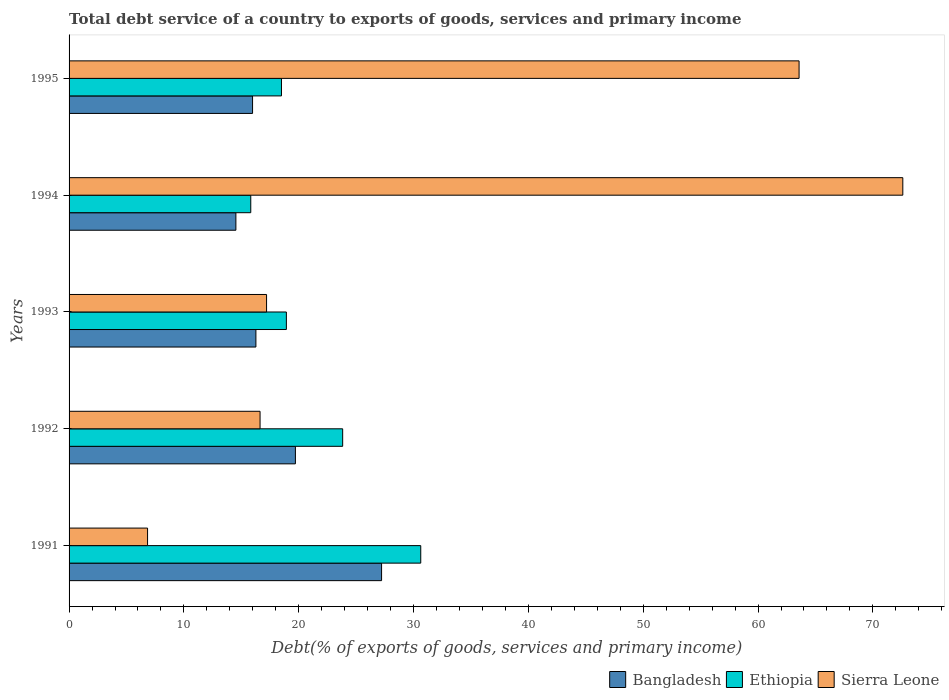How many groups of bars are there?
Ensure brevity in your answer.  5. Are the number of bars on each tick of the Y-axis equal?
Ensure brevity in your answer.  Yes. How many bars are there on the 2nd tick from the top?
Give a very brief answer. 3. How many bars are there on the 2nd tick from the bottom?
Keep it short and to the point. 3. What is the total debt service in Ethiopia in 1993?
Offer a terse response. 18.92. Across all years, what is the maximum total debt service in Sierra Leone?
Your response must be concise. 72.61. Across all years, what is the minimum total debt service in Ethiopia?
Your response must be concise. 15.82. What is the total total debt service in Ethiopia in the graph?
Offer a terse response. 107.7. What is the difference between the total debt service in Bangladesh in 1993 and that in 1994?
Your answer should be compact. 1.74. What is the difference between the total debt service in Bangladesh in 1991 and the total debt service in Ethiopia in 1995?
Offer a very short reply. 8.72. What is the average total debt service in Bangladesh per year?
Your response must be concise. 18.74. In the year 1991, what is the difference between the total debt service in Bangladesh and total debt service in Sierra Leone?
Offer a very short reply. 20.38. What is the ratio of the total debt service in Ethiopia in 1994 to that in 1995?
Give a very brief answer. 0.86. Is the total debt service in Ethiopia in 1994 less than that in 1995?
Your answer should be compact. Yes. What is the difference between the highest and the second highest total debt service in Ethiopia?
Offer a very short reply. 6.8. What is the difference between the highest and the lowest total debt service in Bangladesh?
Ensure brevity in your answer.  12.69. In how many years, is the total debt service in Bangladesh greater than the average total debt service in Bangladesh taken over all years?
Your answer should be compact. 2. What does the 3rd bar from the top in 1993 represents?
Your response must be concise. Bangladesh. Is it the case that in every year, the sum of the total debt service in Bangladesh and total debt service in Ethiopia is greater than the total debt service in Sierra Leone?
Offer a terse response. No. How many years are there in the graph?
Your response must be concise. 5. Does the graph contain grids?
Your answer should be compact. No. Where does the legend appear in the graph?
Offer a terse response. Bottom right. How are the legend labels stacked?
Make the answer very short. Horizontal. What is the title of the graph?
Keep it short and to the point. Total debt service of a country to exports of goods, services and primary income. What is the label or title of the X-axis?
Give a very brief answer. Debt(% of exports of goods, services and primary income). What is the Debt(% of exports of goods, services and primary income) in Bangladesh in 1991?
Ensure brevity in your answer.  27.21. What is the Debt(% of exports of goods, services and primary income) of Ethiopia in 1991?
Give a very brief answer. 30.63. What is the Debt(% of exports of goods, services and primary income) in Sierra Leone in 1991?
Make the answer very short. 6.84. What is the Debt(% of exports of goods, services and primary income) of Bangladesh in 1992?
Give a very brief answer. 19.71. What is the Debt(% of exports of goods, services and primary income) in Ethiopia in 1992?
Your answer should be very brief. 23.83. What is the Debt(% of exports of goods, services and primary income) of Sierra Leone in 1992?
Offer a terse response. 16.63. What is the Debt(% of exports of goods, services and primary income) of Bangladesh in 1993?
Provide a short and direct response. 16.27. What is the Debt(% of exports of goods, services and primary income) of Ethiopia in 1993?
Make the answer very short. 18.92. What is the Debt(% of exports of goods, services and primary income) in Sierra Leone in 1993?
Offer a terse response. 17.2. What is the Debt(% of exports of goods, services and primary income) in Bangladesh in 1994?
Offer a terse response. 14.53. What is the Debt(% of exports of goods, services and primary income) of Ethiopia in 1994?
Your response must be concise. 15.82. What is the Debt(% of exports of goods, services and primary income) in Sierra Leone in 1994?
Your answer should be very brief. 72.61. What is the Debt(% of exports of goods, services and primary income) in Bangladesh in 1995?
Make the answer very short. 15.98. What is the Debt(% of exports of goods, services and primary income) of Ethiopia in 1995?
Your response must be concise. 18.5. What is the Debt(% of exports of goods, services and primary income) of Sierra Leone in 1995?
Offer a terse response. 63.57. Across all years, what is the maximum Debt(% of exports of goods, services and primary income) in Bangladesh?
Offer a terse response. 27.21. Across all years, what is the maximum Debt(% of exports of goods, services and primary income) of Ethiopia?
Offer a terse response. 30.63. Across all years, what is the maximum Debt(% of exports of goods, services and primary income) of Sierra Leone?
Provide a short and direct response. 72.61. Across all years, what is the minimum Debt(% of exports of goods, services and primary income) of Bangladesh?
Your answer should be very brief. 14.53. Across all years, what is the minimum Debt(% of exports of goods, services and primary income) of Ethiopia?
Make the answer very short. 15.82. Across all years, what is the minimum Debt(% of exports of goods, services and primary income) of Sierra Leone?
Keep it short and to the point. 6.84. What is the total Debt(% of exports of goods, services and primary income) of Bangladesh in the graph?
Offer a terse response. 93.7. What is the total Debt(% of exports of goods, services and primary income) in Ethiopia in the graph?
Give a very brief answer. 107.7. What is the total Debt(% of exports of goods, services and primary income) in Sierra Leone in the graph?
Offer a terse response. 176.84. What is the difference between the Debt(% of exports of goods, services and primary income) of Bangladesh in 1991 and that in 1992?
Provide a short and direct response. 7.5. What is the difference between the Debt(% of exports of goods, services and primary income) of Ethiopia in 1991 and that in 1992?
Your answer should be very brief. 6.8. What is the difference between the Debt(% of exports of goods, services and primary income) of Sierra Leone in 1991 and that in 1992?
Offer a very short reply. -9.8. What is the difference between the Debt(% of exports of goods, services and primary income) of Bangladesh in 1991 and that in 1993?
Offer a terse response. 10.94. What is the difference between the Debt(% of exports of goods, services and primary income) in Ethiopia in 1991 and that in 1993?
Provide a succinct answer. 11.7. What is the difference between the Debt(% of exports of goods, services and primary income) of Sierra Leone in 1991 and that in 1993?
Give a very brief answer. -10.36. What is the difference between the Debt(% of exports of goods, services and primary income) of Bangladesh in 1991 and that in 1994?
Offer a terse response. 12.69. What is the difference between the Debt(% of exports of goods, services and primary income) in Ethiopia in 1991 and that in 1994?
Your answer should be very brief. 14.8. What is the difference between the Debt(% of exports of goods, services and primary income) of Sierra Leone in 1991 and that in 1994?
Provide a short and direct response. -65.77. What is the difference between the Debt(% of exports of goods, services and primary income) in Bangladesh in 1991 and that in 1995?
Provide a short and direct response. 11.24. What is the difference between the Debt(% of exports of goods, services and primary income) in Ethiopia in 1991 and that in 1995?
Your response must be concise. 12.13. What is the difference between the Debt(% of exports of goods, services and primary income) of Sierra Leone in 1991 and that in 1995?
Provide a short and direct response. -56.74. What is the difference between the Debt(% of exports of goods, services and primary income) in Bangladesh in 1992 and that in 1993?
Your answer should be compact. 3.44. What is the difference between the Debt(% of exports of goods, services and primary income) in Ethiopia in 1992 and that in 1993?
Your answer should be very brief. 4.9. What is the difference between the Debt(% of exports of goods, services and primary income) in Sierra Leone in 1992 and that in 1993?
Provide a succinct answer. -0.57. What is the difference between the Debt(% of exports of goods, services and primary income) of Bangladesh in 1992 and that in 1994?
Provide a succinct answer. 5.18. What is the difference between the Debt(% of exports of goods, services and primary income) of Ethiopia in 1992 and that in 1994?
Ensure brevity in your answer.  8. What is the difference between the Debt(% of exports of goods, services and primary income) in Sierra Leone in 1992 and that in 1994?
Offer a terse response. -55.97. What is the difference between the Debt(% of exports of goods, services and primary income) of Bangladesh in 1992 and that in 1995?
Your response must be concise. 3.73. What is the difference between the Debt(% of exports of goods, services and primary income) of Ethiopia in 1992 and that in 1995?
Provide a short and direct response. 5.33. What is the difference between the Debt(% of exports of goods, services and primary income) in Sierra Leone in 1992 and that in 1995?
Your answer should be very brief. -46.94. What is the difference between the Debt(% of exports of goods, services and primary income) of Bangladesh in 1993 and that in 1994?
Ensure brevity in your answer.  1.74. What is the difference between the Debt(% of exports of goods, services and primary income) in Ethiopia in 1993 and that in 1994?
Offer a very short reply. 3.1. What is the difference between the Debt(% of exports of goods, services and primary income) in Sierra Leone in 1993 and that in 1994?
Provide a short and direct response. -55.41. What is the difference between the Debt(% of exports of goods, services and primary income) of Bangladesh in 1993 and that in 1995?
Offer a very short reply. 0.29. What is the difference between the Debt(% of exports of goods, services and primary income) in Ethiopia in 1993 and that in 1995?
Keep it short and to the point. 0.43. What is the difference between the Debt(% of exports of goods, services and primary income) in Sierra Leone in 1993 and that in 1995?
Give a very brief answer. -46.37. What is the difference between the Debt(% of exports of goods, services and primary income) in Bangladesh in 1994 and that in 1995?
Keep it short and to the point. -1.45. What is the difference between the Debt(% of exports of goods, services and primary income) in Ethiopia in 1994 and that in 1995?
Your response must be concise. -2.67. What is the difference between the Debt(% of exports of goods, services and primary income) of Sierra Leone in 1994 and that in 1995?
Offer a very short reply. 9.03. What is the difference between the Debt(% of exports of goods, services and primary income) of Bangladesh in 1991 and the Debt(% of exports of goods, services and primary income) of Ethiopia in 1992?
Keep it short and to the point. 3.39. What is the difference between the Debt(% of exports of goods, services and primary income) in Bangladesh in 1991 and the Debt(% of exports of goods, services and primary income) in Sierra Leone in 1992?
Make the answer very short. 10.58. What is the difference between the Debt(% of exports of goods, services and primary income) of Ethiopia in 1991 and the Debt(% of exports of goods, services and primary income) of Sierra Leone in 1992?
Keep it short and to the point. 13.99. What is the difference between the Debt(% of exports of goods, services and primary income) of Bangladesh in 1991 and the Debt(% of exports of goods, services and primary income) of Ethiopia in 1993?
Provide a short and direct response. 8.29. What is the difference between the Debt(% of exports of goods, services and primary income) in Bangladesh in 1991 and the Debt(% of exports of goods, services and primary income) in Sierra Leone in 1993?
Provide a short and direct response. 10.02. What is the difference between the Debt(% of exports of goods, services and primary income) of Ethiopia in 1991 and the Debt(% of exports of goods, services and primary income) of Sierra Leone in 1993?
Keep it short and to the point. 13.43. What is the difference between the Debt(% of exports of goods, services and primary income) of Bangladesh in 1991 and the Debt(% of exports of goods, services and primary income) of Ethiopia in 1994?
Provide a short and direct response. 11.39. What is the difference between the Debt(% of exports of goods, services and primary income) of Bangladesh in 1991 and the Debt(% of exports of goods, services and primary income) of Sierra Leone in 1994?
Your answer should be compact. -45.39. What is the difference between the Debt(% of exports of goods, services and primary income) of Ethiopia in 1991 and the Debt(% of exports of goods, services and primary income) of Sierra Leone in 1994?
Offer a terse response. -41.98. What is the difference between the Debt(% of exports of goods, services and primary income) in Bangladesh in 1991 and the Debt(% of exports of goods, services and primary income) in Ethiopia in 1995?
Offer a terse response. 8.72. What is the difference between the Debt(% of exports of goods, services and primary income) of Bangladesh in 1991 and the Debt(% of exports of goods, services and primary income) of Sierra Leone in 1995?
Your response must be concise. -36.36. What is the difference between the Debt(% of exports of goods, services and primary income) of Ethiopia in 1991 and the Debt(% of exports of goods, services and primary income) of Sierra Leone in 1995?
Make the answer very short. -32.95. What is the difference between the Debt(% of exports of goods, services and primary income) in Bangladesh in 1992 and the Debt(% of exports of goods, services and primary income) in Ethiopia in 1993?
Make the answer very short. 0.79. What is the difference between the Debt(% of exports of goods, services and primary income) in Bangladesh in 1992 and the Debt(% of exports of goods, services and primary income) in Sierra Leone in 1993?
Your answer should be very brief. 2.51. What is the difference between the Debt(% of exports of goods, services and primary income) in Ethiopia in 1992 and the Debt(% of exports of goods, services and primary income) in Sierra Leone in 1993?
Your answer should be very brief. 6.63. What is the difference between the Debt(% of exports of goods, services and primary income) of Bangladesh in 1992 and the Debt(% of exports of goods, services and primary income) of Ethiopia in 1994?
Keep it short and to the point. 3.89. What is the difference between the Debt(% of exports of goods, services and primary income) in Bangladesh in 1992 and the Debt(% of exports of goods, services and primary income) in Sierra Leone in 1994?
Your answer should be compact. -52.9. What is the difference between the Debt(% of exports of goods, services and primary income) in Ethiopia in 1992 and the Debt(% of exports of goods, services and primary income) in Sierra Leone in 1994?
Provide a succinct answer. -48.78. What is the difference between the Debt(% of exports of goods, services and primary income) in Bangladesh in 1992 and the Debt(% of exports of goods, services and primary income) in Ethiopia in 1995?
Provide a short and direct response. 1.21. What is the difference between the Debt(% of exports of goods, services and primary income) in Bangladesh in 1992 and the Debt(% of exports of goods, services and primary income) in Sierra Leone in 1995?
Provide a short and direct response. -43.86. What is the difference between the Debt(% of exports of goods, services and primary income) in Ethiopia in 1992 and the Debt(% of exports of goods, services and primary income) in Sierra Leone in 1995?
Your answer should be very brief. -39.75. What is the difference between the Debt(% of exports of goods, services and primary income) of Bangladesh in 1993 and the Debt(% of exports of goods, services and primary income) of Ethiopia in 1994?
Make the answer very short. 0.45. What is the difference between the Debt(% of exports of goods, services and primary income) in Bangladesh in 1993 and the Debt(% of exports of goods, services and primary income) in Sierra Leone in 1994?
Keep it short and to the point. -56.34. What is the difference between the Debt(% of exports of goods, services and primary income) in Ethiopia in 1993 and the Debt(% of exports of goods, services and primary income) in Sierra Leone in 1994?
Provide a succinct answer. -53.68. What is the difference between the Debt(% of exports of goods, services and primary income) in Bangladesh in 1993 and the Debt(% of exports of goods, services and primary income) in Ethiopia in 1995?
Provide a succinct answer. -2.23. What is the difference between the Debt(% of exports of goods, services and primary income) in Bangladesh in 1993 and the Debt(% of exports of goods, services and primary income) in Sierra Leone in 1995?
Offer a terse response. -47.3. What is the difference between the Debt(% of exports of goods, services and primary income) of Ethiopia in 1993 and the Debt(% of exports of goods, services and primary income) of Sierra Leone in 1995?
Give a very brief answer. -44.65. What is the difference between the Debt(% of exports of goods, services and primary income) in Bangladesh in 1994 and the Debt(% of exports of goods, services and primary income) in Ethiopia in 1995?
Make the answer very short. -3.97. What is the difference between the Debt(% of exports of goods, services and primary income) of Bangladesh in 1994 and the Debt(% of exports of goods, services and primary income) of Sierra Leone in 1995?
Make the answer very short. -49.05. What is the difference between the Debt(% of exports of goods, services and primary income) in Ethiopia in 1994 and the Debt(% of exports of goods, services and primary income) in Sierra Leone in 1995?
Ensure brevity in your answer.  -47.75. What is the average Debt(% of exports of goods, services and primary income) of Bangladesh per year?
Keep it short and to the point. 18.74. What is the average Debt(% of exports of goods, services and primary income) in Ethiopia per year?
Offer a very short reply. 21.54. What is the average Debt(% of exports of goods, services and primary income) in Sierra Leone per year?
Offer a very short reply. 35.37. In the year 1991, what is the difference between the Debt(% of exports of goods, services and primary income) of Bangladesh and Debt(% of exports of goods, services and primary income) of Ethiopia?
Offer a very short reply. -3.41. In the year 1991, what is the difference between the Debt(% of exports of goods, services and primary income) of Bangladesh and Debt(% of exports of goods, services and primary income) of Sierra Leone?
Give a very brief answer. 20.38. In the year 1991, what is the difference between the Debt(% of exports of goods, services and primary income) in Ethiopia and Debt(% of exports of goods, services and primary income) in Sierra Leone?
Offer a very short reply. 23.79. In the year 1992, what is the difference between the Debt(% of exports of goods, services and primary income) of Bangladesh and Debt(% of exports of goods, services and primary income) of Ethiopia?
Your answer should be very brief. -4.12. In the year 1992, what is the difference between the Debt(% of exports of goods, services and primary income) of Bangladesh and Debt(% of exports of goods, services and primary income) of Sierra Leone?
Offer a terse response. 3.08. In the year 1992, what is the difference between the Debt(% of exports of goods, services and primary income) in Ethiopia and Debt(% of exports of goods, services and primary income) in Sierra Leone?
Your response must be concise. 7.19. In the year 1993, what is the difference between the Debt(% of exports of goods, services and primary income) of Bangladesh and Debt(% of exports of goods, services and primary income) of Ethiopia?
Give a very brief answer. -2.65. In the year 1993, what is the difference between the Debt(% of exports of goods, services and primary income) in Bangladesh and Debt(% of exports of goods, services and primary income) in Sierra Leone?
Give a very brief answer. -0.93. In the year 1993, what is the difference between the Debt(% of exports of goods, services and primary income) of Ethiopia and Debt(% of exports of goods, services and primary income) of Sierra Leone?
Your answer should be compact. 1.73. In the year 1994, what is the difference between the Debt(% of exports of goods, services and primary income) in Bangladesh and Debt(% of exports of goods, services and primary income) in Ethiopia?
Offer a very short reply. -1.3. In the year 1994, what is the difference between the Debt(% of exports of goods, services and primary income) of Bangladesh and Debt(% of exports of goods, services and primary income) of Sierra Leone?
Your answer should be very brief. -58.08. In the year 1994, what is the difference between the Debt(% of exports of goods, services and primary income) of Ethiopia and Debt(% of exports of goods, services and primary income) of Sierra Leone?
Ensure brevity in your answer.  -56.78. In the year 1995, what is the difference between the Debt(% of exports of goods, services and primary income) of Bangladesh and Debt(% of exports of goods, services and primary income) of Ethiopia?
Your answer should be very brief. -2.52. In the year 1995, what is the difference between the Debt(% of exports of goods, services and primary income) of Bangladesh and Debt(% of exports of goods, services and primary income) of Sierra Leone?
Provide a short and direct response. -47.59. In the year 1995, what is the difference between the Debt(% of exports of goods, services and primary income) of Ethiopia and Debt(% of exports of goods, services and primary income) of Sierra Leone?
Provide a short and direct response. -45.08. What is the ratio of the Debt(% of exports of goods, services and primary income) in Bangladesh in 1991 to that in 1992?
Keep it short and to the point. 1.38. What is the ratio of the Debt(% of exports of goods, services and primary income) of Ethiopia in 1991 to that in 1992?
Make the answer very short. 1.29. What is the ratio of the Debt(% of exports of goods, services and primary income) of Sierra Leone in 1991 to that in 1992?
Keep it short and to the point. 0.41. What is the ratio of the Debt(% of exports of goods, services and primary income) of Bangladesh in 1991 to that in 1993?
Your answer should be compact. 1.67. What is the ratio of the Debt(% of exports of goods, services and primary income) in Ethiopia in 1991 to that in 1993?
Offer a very short reply. 1.62. What is the ratio of the Debt(% of exports of goods, services and primary income) in Sierra Leone in 1991 to that in 1993?
Your response must be concise. 0.4. What is the ratio of the Debt(% of exports of goods, services and primary income) of Bangladesh in 1991 to that in 1994?
Give a very brief answer. 1.87. What is the ratio of the Debt(% of exports of goods, services and primary income) in Ethiopia in 1991 to that in 1994?
Provide a short and direct response. 1.94. What is the ratio of the Debt(% of exports of goods, services and primary income) in Sierra Leone in 1991 to that in 1994?
Ensure brevity in your answer.  0.09. What is the ratio of the Debt(% of exports of goods, services and primary income) in Bangladesh in 1991 to that in 1995?
Make the answer very short. 1.7. What is the ratio of the Debt(% of exports of goods, services and primary income) of Ethiopia in 1991 to that in 1995?
Provide a succinct answer. 1.66. What is the ratio of the Debt(% of exports of goods, services and primary income) in Sierra Leone in 1991 to that in 1995?
Provide a short and direct response. 0.11. What is the ratio of the Debt(% of exports of goods, services and primary income) in Bangladesh in 1992 to that in 1993?
Your answer should be very brief. 1.21. What is the ratio of the Debt(% of exports of goods, services and primary income) in Ethiopia in 1992 to that in 1993?
Offer a very short reply. 1.26. What is the ratio of the Debt(% of exports of goods, services and primary income) in Sierra Leone in 1992 to that in 1993?
Provide a short and direct response. 0.97. What is the ratio of the Debt(% of exports of goods, services and primary income) in Bangladesh in 1992 to that in 1994?
Offer a very short reply. 1.36. What is the ratio of the Debt(% of exports of goods, services and primary income) in Ethiopia in 1992 to that in 1994?
Offer a very short reply. 1.51. What is the ratio of the Debt(% of exports of goods, services and primary income) in Sierra Leone in 1992 to that in 1994?
Your answer should be very brief. 0.23. What is the ratio of the Debt(% of exports of goods, services and primary income) of Bangladesh in 1992 to that in 1995?
Provide a succinct answer. 1.23. What is the ratio of the Debt(% of exports of goods, services and primary income) of Ethiopia in 1992 to that in 1995?
Your answer should be very brief. 1.29. What is the ratio of the Debt(% of exports of goods, services and primary income) in Sierra Leone in 1992 to that in 1995?
Offer a very short reply. 0.26. What is the ratio of the Debt(% of exports of goods, services and primary income) of Bangladesh in 1993 to that in 1994?
Ensure brevity in your answer.  1.12. What is the ratio of the Debt(% of exports of goods, services and primary income) in Ethiopia in 1993 to that in 1994?
Offer a terse response. 1.2. What is the ratio of the Debt(% of exports of goods, services and primary income) in Sierra Leone in 1993 to that in 1994?
Ensure brevity in your answer.  0.24. What is the ratio of the Debt(% of exports of goods, services and primary income) in Bangladesh in 1993 to that in 1995?
Provide a short and direct response. 1.02. What is the ratio of the Debt(% of exports of goods, services and primary income) in Ethiopia in 1993 to that in 1995?
Your answer should be compact. 1.02. What is the ratio of the Debt(% of exports of goods, services and primary income) of Sierra Leone in 1993 to that in 1995?
Give a very brief answer. 0.27. What is the ratio of the Debt(% of exports of goods, services and primary income) of Bangladesh in 1994 to that in 1995?
Your answer should be very brief. 0.91. What is the ratio of the Debt(% of exports of goods, services and primary income) of Ethiopia in 1994 to that in 1995?
Make the answer very short. 0.86. What is the ratio of the Debt(% of exports of goods, services and primary income) of Sierra Leone in 1994 to that in 1995?
Your answer should be compact. 1.14. What is the difference between the highest and the second highest Debt(% of exports of goods, services and primary income) in Bangladesh?
Offer a very short reply. 7.5. What is the difference between the highest and the second highest Debt(% of exports of goods, services and primary income) of Ethiopia?
Keep it short and to the point. 6.8. What is the difference between the highest and the second highest Debt(% of exports of goods, services and primary income) in Sierra Leone?
Make the answer very short. 9.03. What is the difference between the highest and the lowest Debt(% of exports of goods, services and primary income) in Bangladesh?
Your response must be concise. 12.69. What is the difference between the highest and the lowest Debt(% of exports of goods, services and primary income) in Ethiopia?
Make the answer very short. 14.8. What is the difference between the highest and the lowest Debt(% of exports of goods, services and primary income) of Sierra Leone?
Your response must be concise. 65.77. 